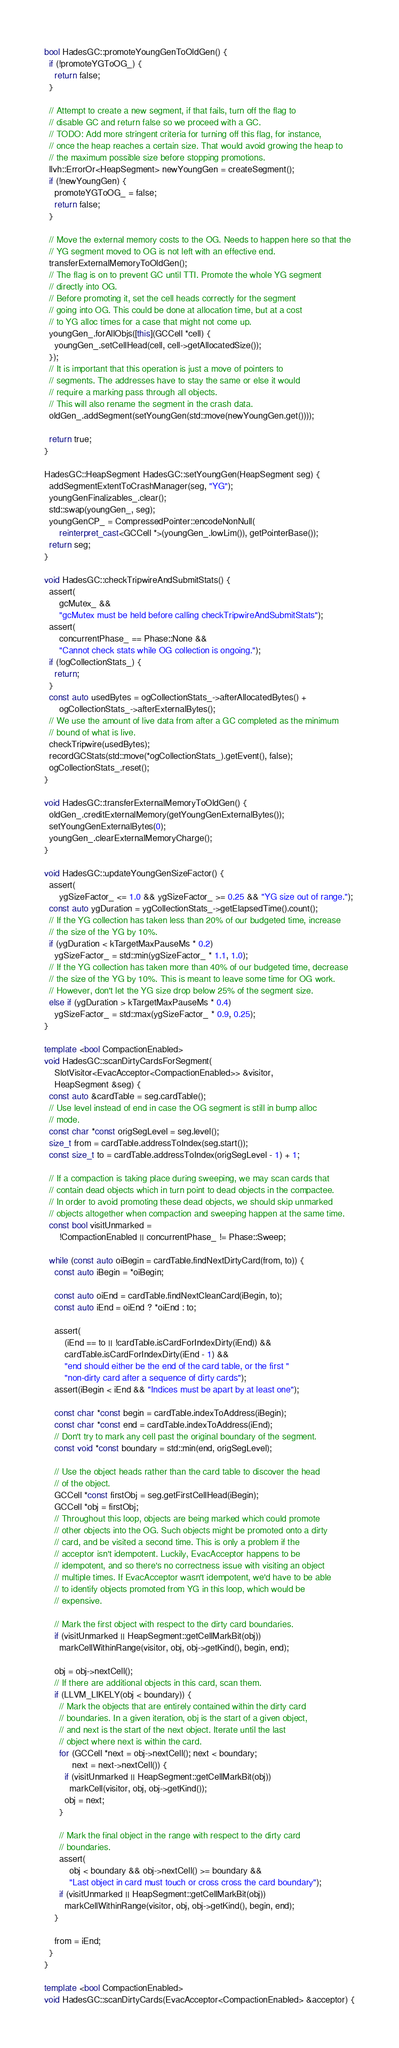<code> <loc_0><loc_0><loc_500><loc_500><_C++_>bool HadesGC::promoteYoungGenToOldGen() {
  if (!promoteYGToOG_) {
    return false;
  }

  // Attempt to create a new segment, if that fails, turn off the flag to
  // disable GC and return false so we proceed with a GC.
  // TODO: Add more stringent criteria for turning off this flag, for instance,
  // once the heap reaches a certain size. That would avoid growing the heap to
  // the maximum possible size before stopping promotions.
  llvh::ErrorOr<HeapSegment> newYoungGen = createSegment();
  if (!newYoungGen) {
    promoteYGToOG_ = false;
    return false;
  }

  // Move the external memory costs to the OG. Needs to happen here so that the
  // YG segment moved to OG is not left with an effective end.
  transferExternalMemoryToOldGen();
  // The flag is on to prevent GC until TTI. Promote the whole YG segment
  // directly into OG.
  // Before promoting it, set the cell heads correctly for the segment
  // going into OG. This could be done at allocation time, but at a cost
  // to YG alloc times for a case that might not come up.
  youngGen_.forAllObjs([this](GCCell *cell) {
    youngGen_.setCellHead(cell, cell->getAllocatedSize());
  });
  // It is important that this operation is just a move of pointers to
  // segments. The addresses have to stay the same or else it would
  // require a marking pass through all objects.
  // This will also rename the segment in the crash data.
  oldGen_.addSegment(setYoungGen(std::move(newYoungGen.get())));

  return true;
}

HadesGC::HeapSegment HadesGC::setYoungGen(HeapSegment seg) {
  addSegmentExtentToCrashManager(seg, "YG");
  youngGenFinalizables_.clear();
  std::swap(youngGen_, seg);
  youngGenCP_ = CompressedPointer::encodeNonNull(
      reinterpret_cast<GCCell *>(youngGen_.lowLim()), getPointerBase());
  return seg;
}

void HadesGC::checkTripwireAndSubmitStats() {
  assert(
      gcMutex_ &&
      "gcMutex must be held before calling checkTripwireAndSubmitStats");
  assert(
      concurrentPhase_ == Phase::None &&
      "Cannot check stats while OG collection is ongoing.");
  if (!ogCollectionStats_) {
    return;
  }
  const auto usedBytes = ogCollectionStats_->afterAllocatedBytes() +
      ogCollectionStats_->afterExternalBytes();
  // We use the amount of live data from after a GC completed as the minimum
  // bound of what is live.
  checkTripwire(usedBytes);
  recordGCStats(std::move(*ogCollectionStats_).getEvent(), false);
  ogCollectionStats_.reset();
}

void HadesGC::transferExternalMemoryToOldGen() {
  oldGen_.creditExternalMemory(getYoungGenExternalBytes());
  setYoungGenExternalBytes(0);
  youngGen_.clearExternalMemoryCharge();
}

void HadesGC::updateYoungGenSizeFactor() {
  assert(
      ygSizeFactor_ <= 1.0 && ygSizeFactor_ >= 0.25 && "YG size out of range.");
  const auto ygDuration = ygCollectionStats_->getElapsedTime().count();
  // If the YG collection has taken less than 20% of our budgeted time, increase
  // the size of the YG by 10%.
  if (ygDuration < kTargetMaxPauseMs * 0.2)
    ygSizeFactor_ = std::min(ygSizeFactor_ * 1.1, 1.0);
  // If the YG collection has taken more than 40% of our budgeted time, decrease
  // the size of the YG by 10%. This is meant to leave some time for OG work.
  // However, don't let the YG size drop below 25% of the segment size.
  else if (ygDuration > kTargetMaxPauseMs * 0.4)
    ygSizeFactor_ = std::max(ygSizeFactor_ * 0.9, 0.25);
}

template <bool CompactionEnabled>
void HadesGC::scanDirtyCardsForSegment(
    SlotVisitor<EvacAcceptor<CompactionEnabled>> &visitor,
    HeapSegment &seg) {
  const auto &cardTable = seg.cardTable();
  // Use level instead of end in case the OG segment is still in bump alloc
  // mode.
  const char *const origSegLevel = seg.level();
  size_t from = cardTable.addressToIndex(seg.start());
  const size_t to = cardTable.addressToIndex(origSegLevel - 1) + 1;

  // If a compaction is taking place during sweeping, we may scan cards that
  // contain dead objects which in turn point to dead objects in the compactee.
  // In order to avoid promoting these dead objects, we should skip unmarked
  // objects altogether when compaction and sweeping happen at the same time.
  const bool visitUnmarked =
      !CompactionEnabled || concurrentPhase_ != Phase::Sweep;

  while (const auto oiBegin = cardTable.findNextDirtyCard(from, to)) {
    const auto iBegin = *oiBegin;

    const auto oiEnd = cardTable.findNextCleanCard(iBegin, to);
    const auto iEnd = oiEnd ? *oiEnd : to;

    assert(
        (iEnd == to || !cardTable.isCardForIndexDirty(iEnd)) &&
        cardTable.isCardForIndexDirty(iEnd - 1) &&
        "end should either be the end of the card table, or the first "
        "non-dirty card after a sequence of dirty cards");
    assert(iBegin < iEnd && "Indices must be apart by at least one");

    const char *const begin = cardTable.indexToAddress(iBegin);
    const char *const end = cardTable.indexToAddress(iEnd);
    // Don't try to mark any cell past the original boundary of the segment.
    const void *const boundary = std::min(end, origSegLevel);

    // Use the object heads rather than the card table to discover the head
    // of the object.
    GCCell *const firstObj = seg.getFirstCellHead(iBegin);
    GCCell *obj = firstObj;
    // Throughout this loop, objects are being marked which could promote
    // other objects into the OG. Such objects might be promoted onto a dirty
    // card, and be visited a second time. This is only a problem if the
    // acceptor isn't idempotent. Luckily, EvacAcceptor happens to be
    // idempotent, and so there's no correctness issue with visiting an object
    // multiple times. If EvacAcceptor wasn't idempotent, we'd have to be able
    // to identify objects promoted from YG in this loop, which would be
    // expensive.

    // Mark the first object with respect to the dirty card boundaries.
    if (visitUnmarked || HeapSegment::getCellMarkBit(obj))
      markCellWithinRange(visitor, obj, obj->getKind(), begin, end);

    obj = obj->nextCell();
    // If there are additional objects in this card, scan them.
    if (LLVM_LIKELY(obj < boundary)) {
      // Mark the objects that are entirely contained within the dirty card
      // boundaries. In a given iteration, obj is the start of a given object,
      // and next is the start of the next object. Iterate until the last
      // object where next is within the card.
      for (GCCell *next = obj->nextCell(); next < boundary;
           next = next->nextCell()) {
        if (visitUnmarked || HeapSegment::getCellMarkBit(obj))
          markCell(visitor, obj, obj->getKind());
        obj = next;
      }

      // Mark the final object in the range with respect to the dirty card
      // boundaries.
      assert(
          obj < boundary && obj->nextCell() >= boundary &&
          "Last object in card must touch or cross cross the card boundary");
      if (visitUnmarked || HeapSegment::getCellMarkBit(obj))
        markCellWithinRange(visitor, obj, obj->getKind(), begin, end);
    }

    from = iEnd;
  }
}

template <bool CompactionEnabled>
void HadesGC::scanDirtyCards(EvacAcceptor<CompactionEnabled> &acceptor) {</code> 